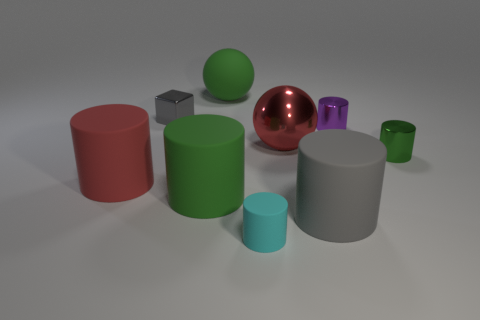How many tiny things are green things or gray things?
Keep it short and to the point. 2. Is the cylinder in front of the gray rubber object made of the same material as the small block?
Your answer should be very brief. No. The gray object right of the big green rubber thing that is behind the red object that is on the right side of the large green matte cylinder is what shape?
Keep it short and to the point. Cylinder. How many green things are either large balls or cubes?
Give a very brief answer. 1. Is the number of gray metallic objects in front of the green shiny object the same as the number of small objects that are left of the green matte cylinder?
Provide a succinct answer. No. Is the shape of the green thing that is to the right of the big gray cylinder the same as the red thing that is left of the cyan object?
Make the answer very short. Yes. Is there anything else that is the same shape as the small gray metal thing?
Ensure brevity in your answer.  No. There is a green thing that is the same material as the red sphere; what shape is it?
Offer a very short reply. Cylinder. Is the number of small shiny cylinders that are in front of the big metallic ball the same as the number of red matte things?
Give a very brief answer. Yes. Are the big cylinder that is right of the large shiny sphere and the small cylinder to the right of the tiny purple object made of the same material?
Your response must be concise. No. 